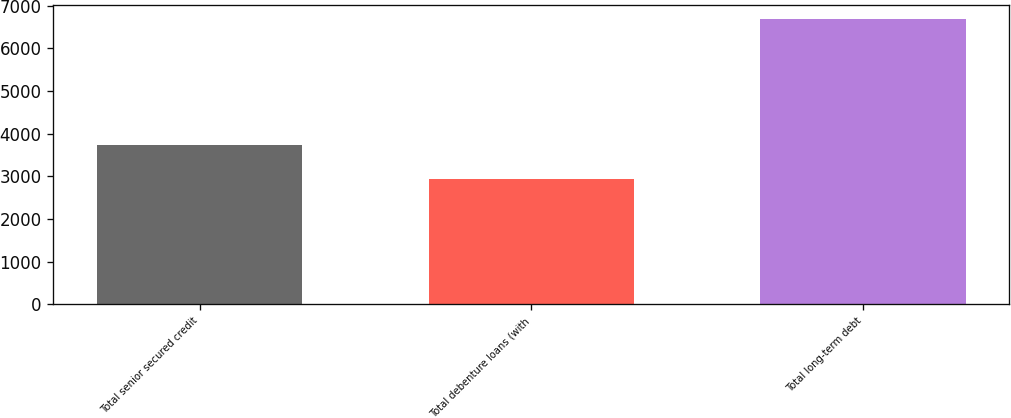<chart> <loc_0><loc_0><loc_500><loc_500><bar_chart><fcel>Total senior secured credit<fcel>Total debenture loans (with<fcel>Total long-term debt<nl><fcel>3742<fcel>2944<fcel>6694<nl></chart> 